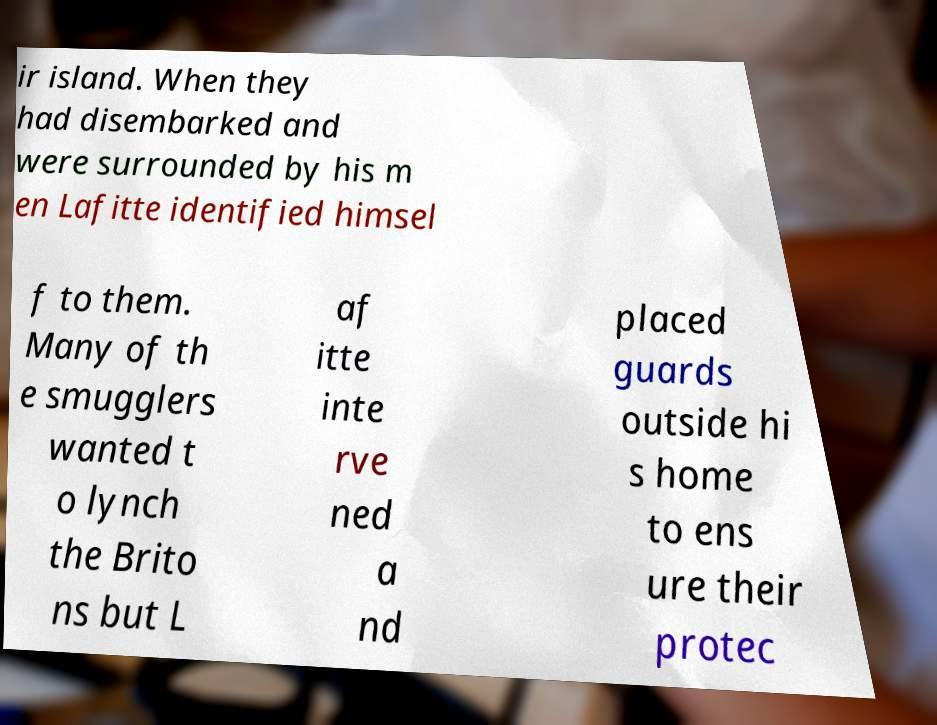Can you accurately transcribe the text from the provided image for me? ir island. When they had disembarked and were surrounded by his m en Lafitte identified himsel f to them. Many of th e smugglers wanted t o lynch the Brito ns but L af itte inte rve ned a nd placed guards outside hi s home to ens ure their protec 